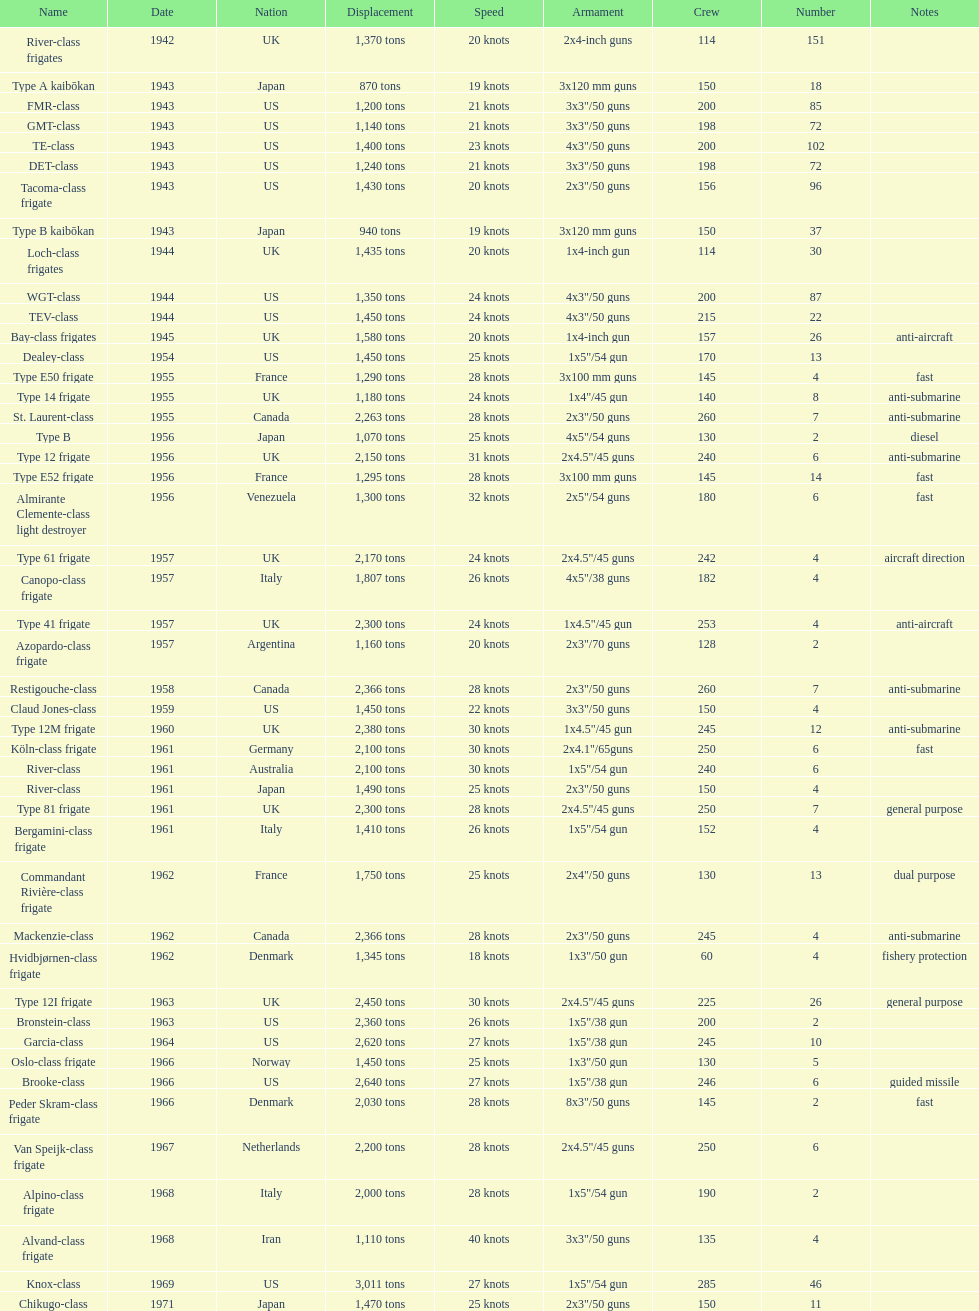Which name has the largest displacement? Knox-class. 